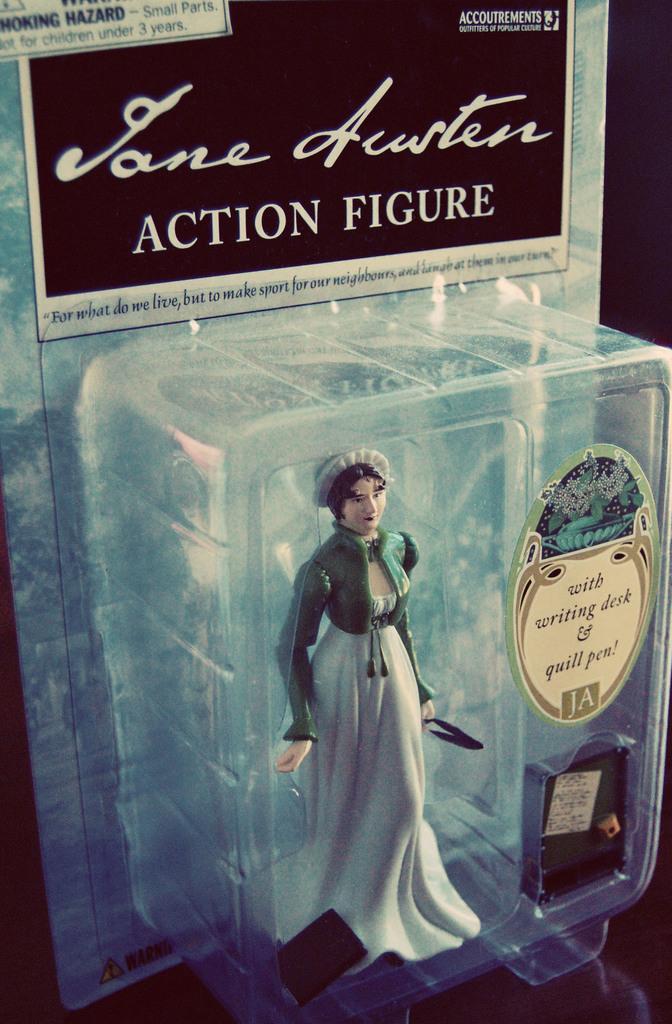How would you summarize this image in a sentence or two? In this picture I see a doll in a box and I see stickers on which there is something written. 